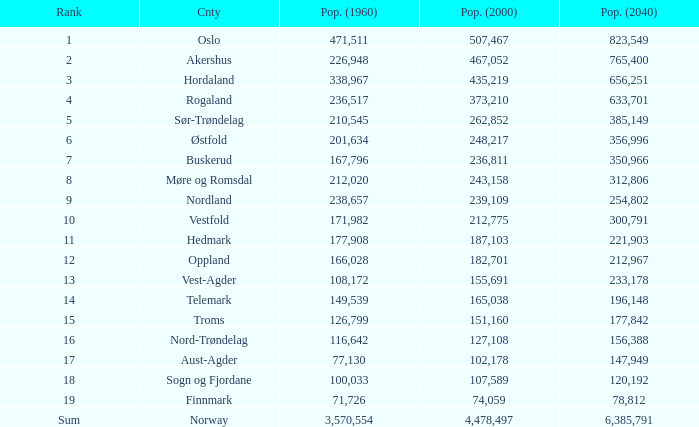With a 2000 population of 507,467, what was the amount of people living in oslo in 1960? None. Would you mind parsing the complete table? {'header': ['Rank', 'Cnty', 'Pop. (1960)', 'Pop. (2000)', 'Pop. (2040)'], 'rows': [['1', 'Oslo', '471,511', '507,467', '823,549'], ['2', 'Akershus', '226,948', '467,052', '765,400'], ['3', 'Hordaland', '338,967', '435,219', '656,251'], ['4', 'Rogaland', '236,517', '373,210', '633,701'], ['5', 'Sør-Trøndelag', '210,545', '262,852', '385,149'], ['6', 'Østfold', '201,634', '248,217', '356,996'], ['7', 'Buskerud', '167,796', '236,811', '350,966'], ['8', 'Møre og Romsdal', '212,020', '243,158', '312,806'], ['9', 'Nordland', '238,657', '239,109', '254,802'], ['10', 'Vestfold', '171,982', '212,775', '300,791'], ['11', 'Hedmark', '177,908', '187,103', '221,903'], ['12', 'Oppland', '166,028', '182,701', '212,967'], ['13', 'Vest-Agder', '108,172', '155,691', '233,178'], ['14', 'Telemark', '149,539', '165,038', '196,148'], ['15', 'Troms', '126,799', '151,160', '177,842'], ['16', 'Nord-Trøndelag', '116,642', '127,108', '156,388'], ['17', 'Aust-Agder', '77,130', '102,178', '147,949'], ['18', 'Sogn og Fjordane', '100,033', '107,589', '120,192'], ['19', 'Finnmark', '71,726', '74,059', '78,812'], ['Sum', 'Norway', '3,570,554', '4,478,497', '6,385,791']]} 